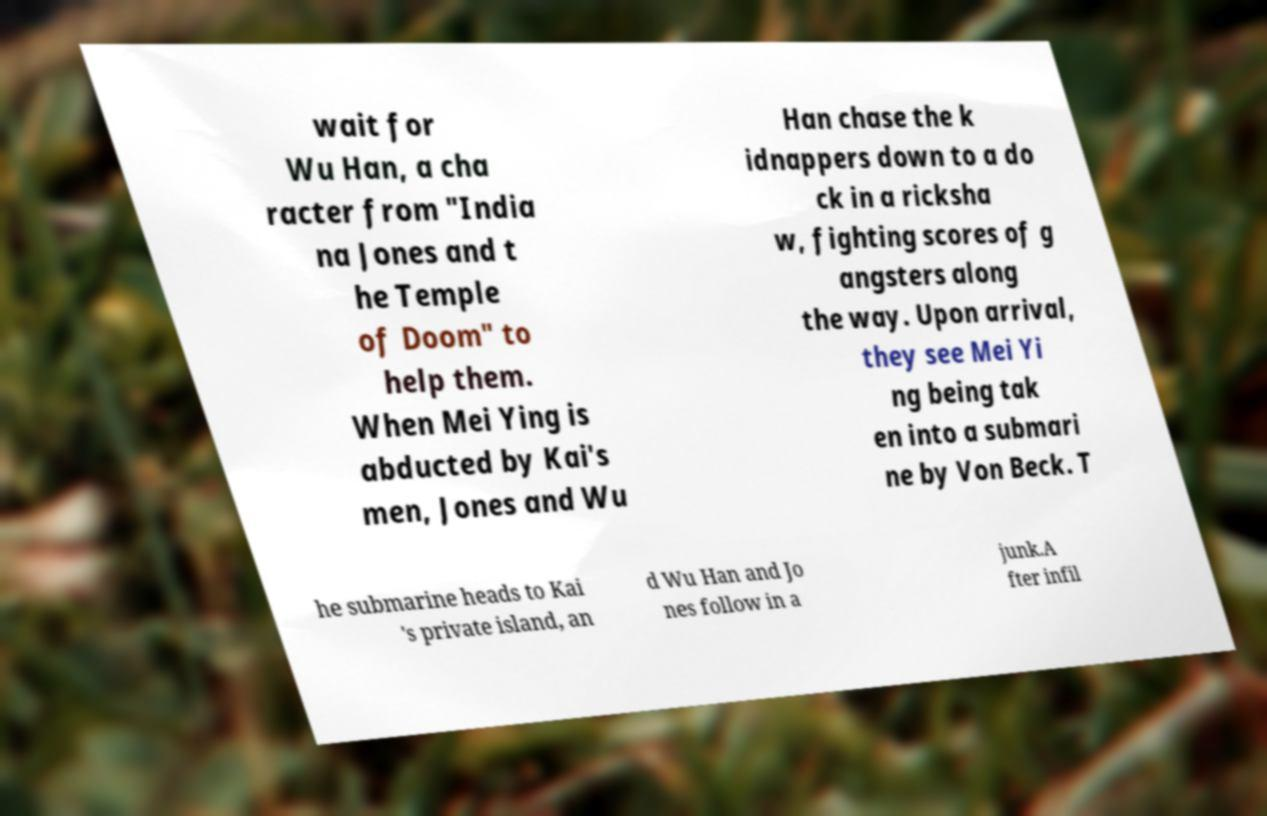For documentation purposes, I need the text within this image transcribed. Could you provide that? wait for Wu Han, a cha racter from "India na Jones and t he Temple of Doom" to help them. When Mei Ying is abducted by Kai's men, Jones and Wu Han chase the k idnappers down to a do ck in a ricksha w, fighting scores of g angsters along the way. Upon arrival, they see Mei Yi ng being tak en into a submari ne by Von Beck. T he submarine heads to Kai 's private island, an d Wu Han and Jo nes follow in a junk.A fter infil 